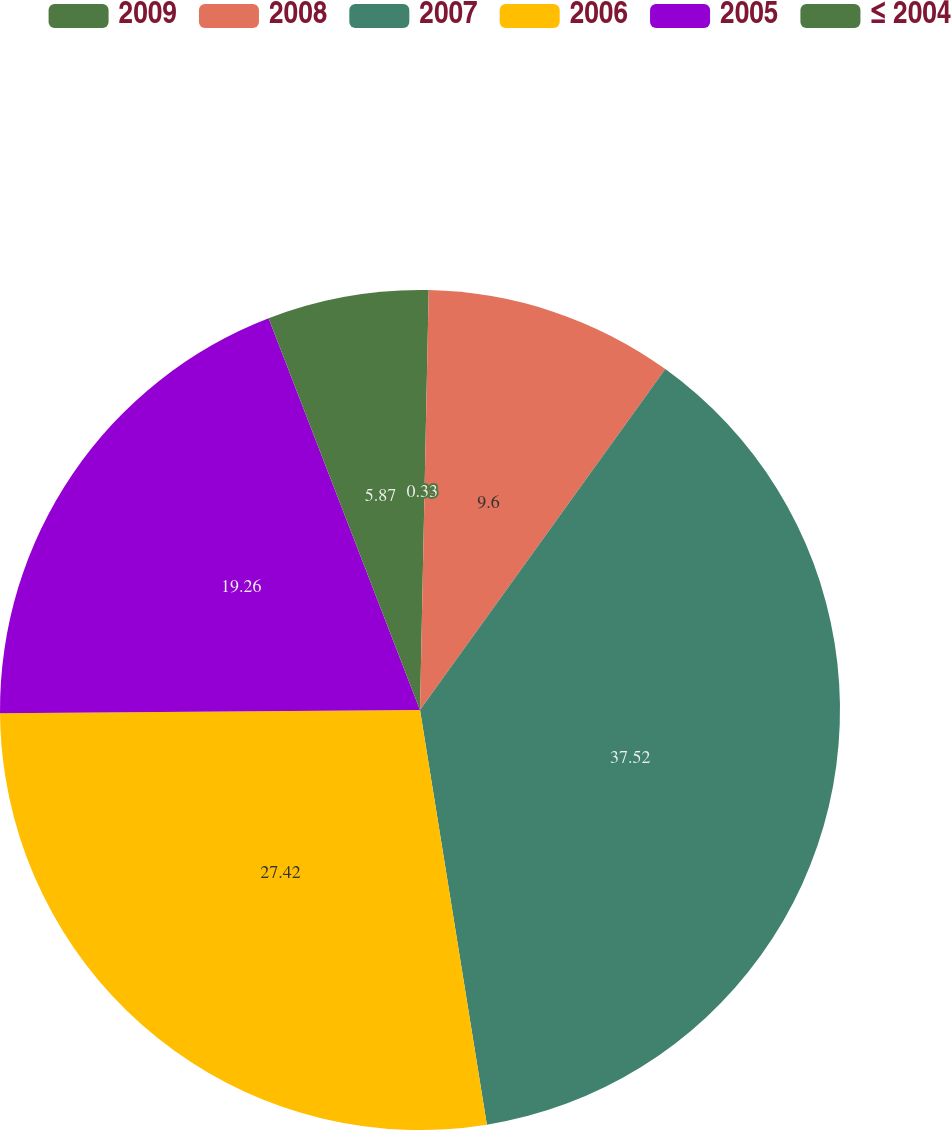Convert chart to OTSL. <chart><loc_0><loc_0><loc_500><loc_500><pie_chart><fcel>2009<fcel>2008<fcel>2007<fcel>2006<fcel>2005<fcel>≤ 2004<nl><fcel>0.33%<fcel>9.6%<fcel>37.53%<fcel>27.42%<fcel>19.26%<fcel>5.87%<nl></chart> 